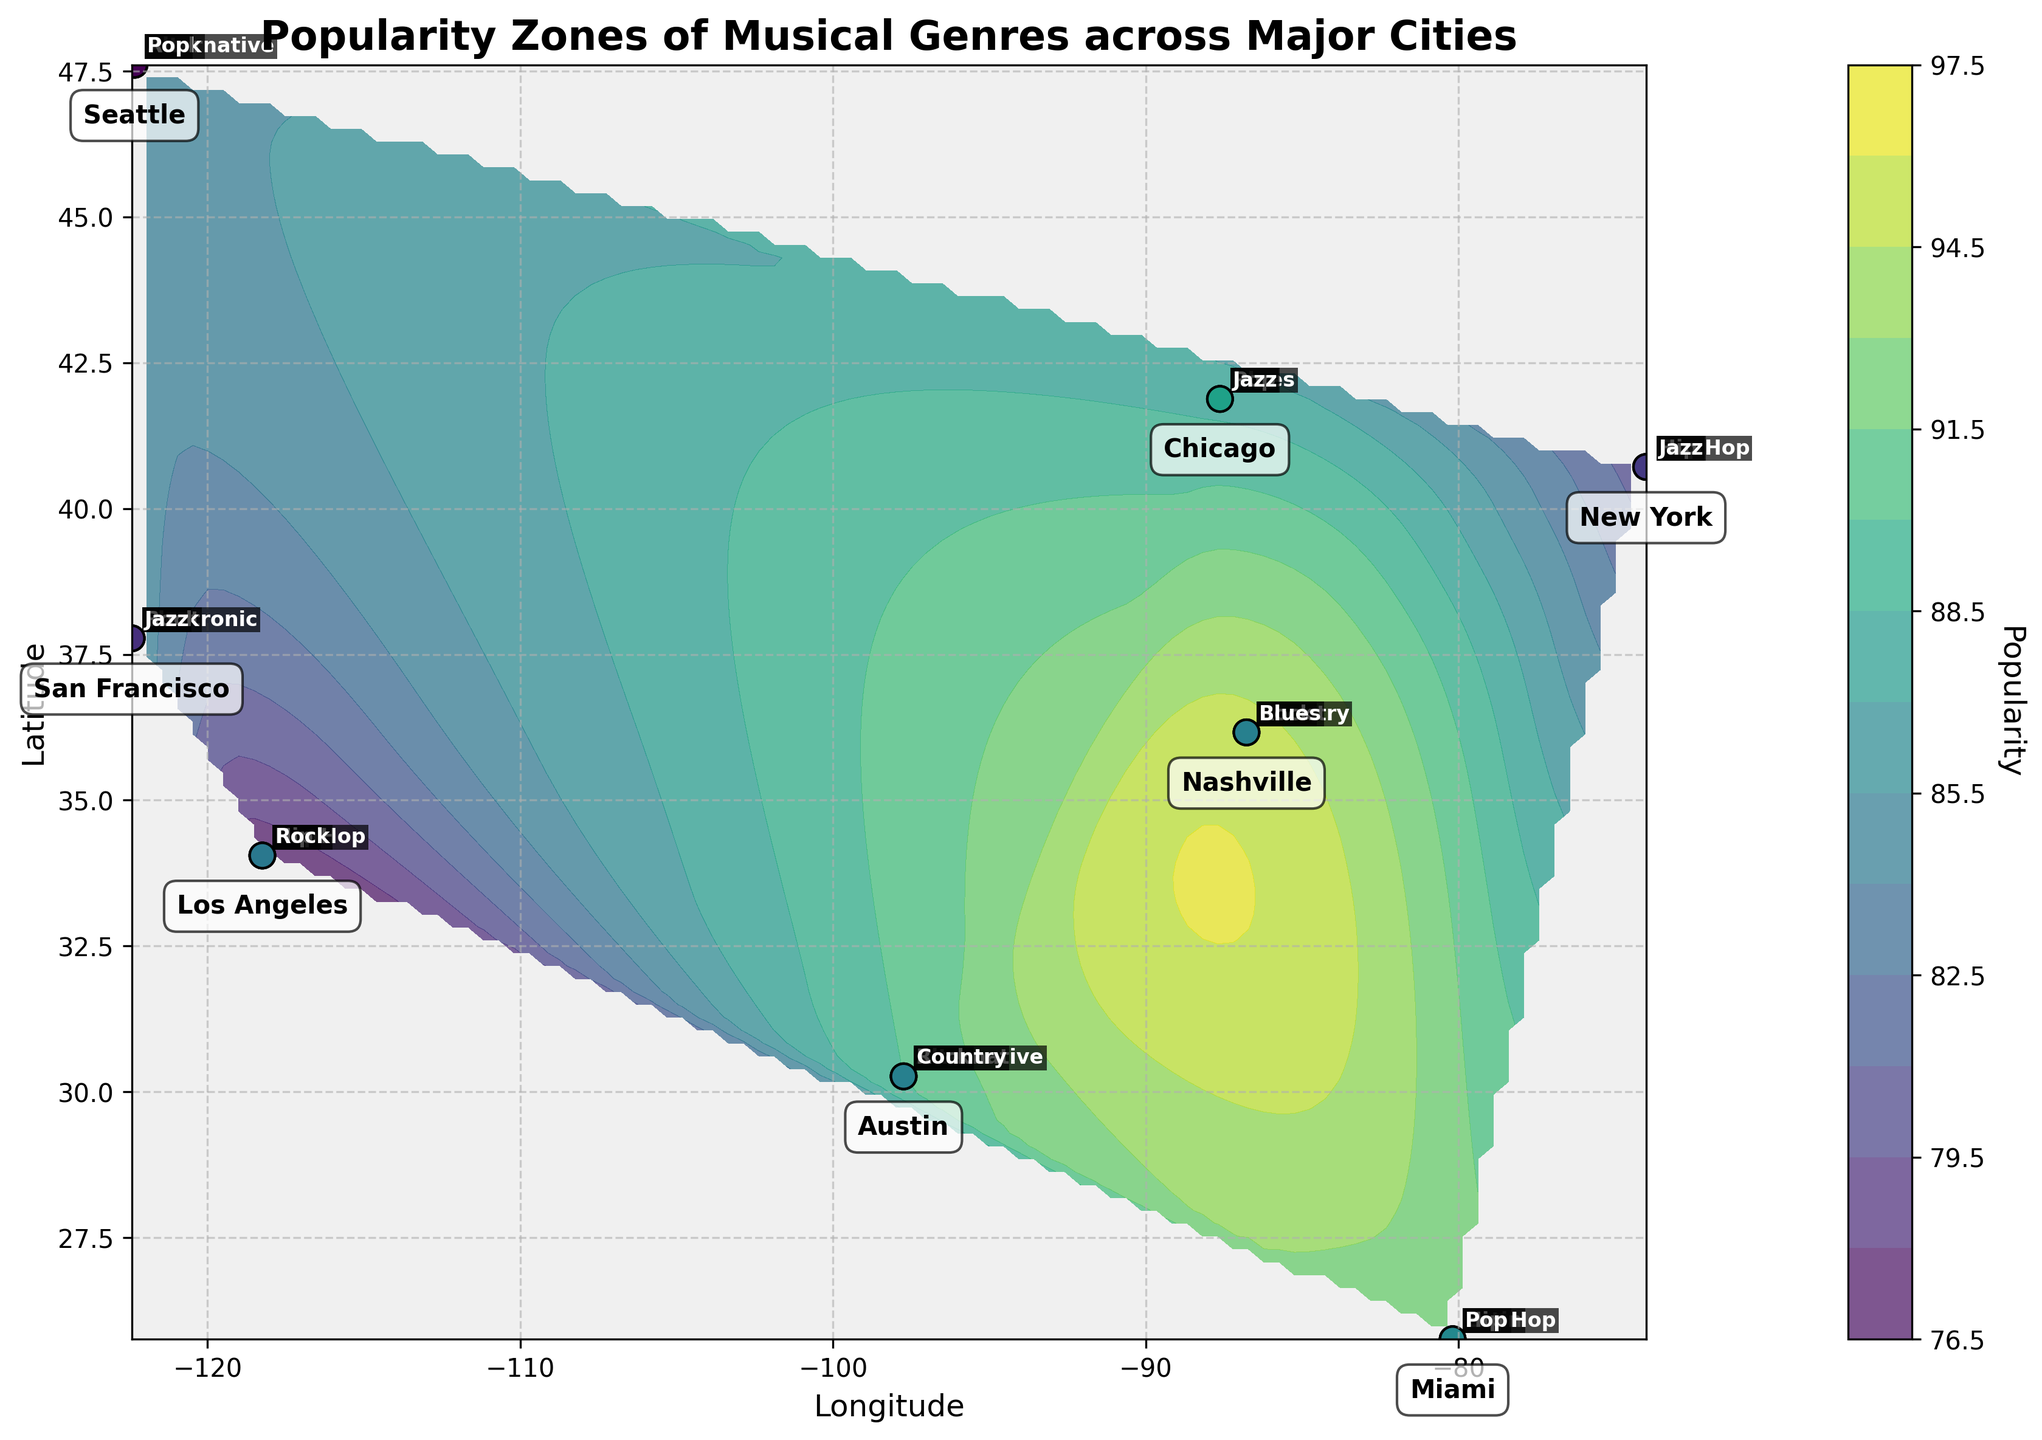What's the title of the figure? The title is usually displayed prominently at the top of the figure. In this case, it's clearly visible in bold text.
Answer: Popularity Zones of Musical Genres across Major Cities How many cities are labeled on the figure? The city labels are annotated directly on the plot. You can count the distinct city names visible. There are 8 unique cities labeled.
Answer: 8 Which genre is the most popular in Miami? The genre labels are positioned next to the scatter points on the plot. Next to Miami, the genre with the highest popularity is indicated. Latin has a popularity of 92.
Answer: Latin Between Nashville and Chicago, which city has a higher popularity in the Blues genre? Compare the labeled values near Nashville and Chicago for the Blues genre. In Nashville, the popularity for Blues is 78, while in Chicago, it is 88.
Answer: Chicago Which genre in Seattle has the lowest popularity, and what is its value? Look at the genre labels and their popularity values near Seattle. Alternative: 85, Rock: 80, Pop: 65. Pop has the lowest popularity at 65.
Answer: Pop with 65 What is the average popularity of the 'Pop' genre across all cities? Add the popularity values of the Pop genre across cities and divide by the number of cities where Pop is listed. Values: 80, 85, 75, 79, 65. (80+85+75+79+65) / 5 = 76.8
Answer: 76.8 Which city shows the highest popularity in the Hip Hop genre, and what is the value? Compare the popularity values of Hip Hop for the cities where it's labeled. New York: 90, Los Angeles: 93, Miami: 71. Los Angeles has the highest value, 93.
Answer: Los Angeles with 93 For which genre is Nashville distinctly known, based on popularity, and why? In Nashville, the highest popularity value should be considered to answer this question. Country has the highest popularity at 95, making it distinctly associated with this genre.
Answer: Country with 95 Which genres have a popularity greater than 80 in Los Angeles? Examine the genres and their popularity values next to Los Angeles. Pop: 85, Hip Hop: 93, Rock: 77. Pop and Hip Hop are above 80.
Answer: Pop and Hip Hop What is the total popularity of Rock genre in cities where it's labeled? Sum the Rock genre popularity values from the labeled points. Los Angeles: 77, Nashville: 65, Seattle: 80, San Francisco: 73, Austin: 84. (77+65+80+73+84) = 379
Answer: 379 